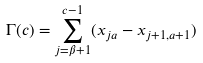<formula> <loc_0><loc_0><loc_500><loc_500>\Gamma ( c ) = \sum _ { j = \beta + 1 } ^ { c - 1 } ( x _ { j a } - x _ { j + 1 , a + 1 } )</formula> 